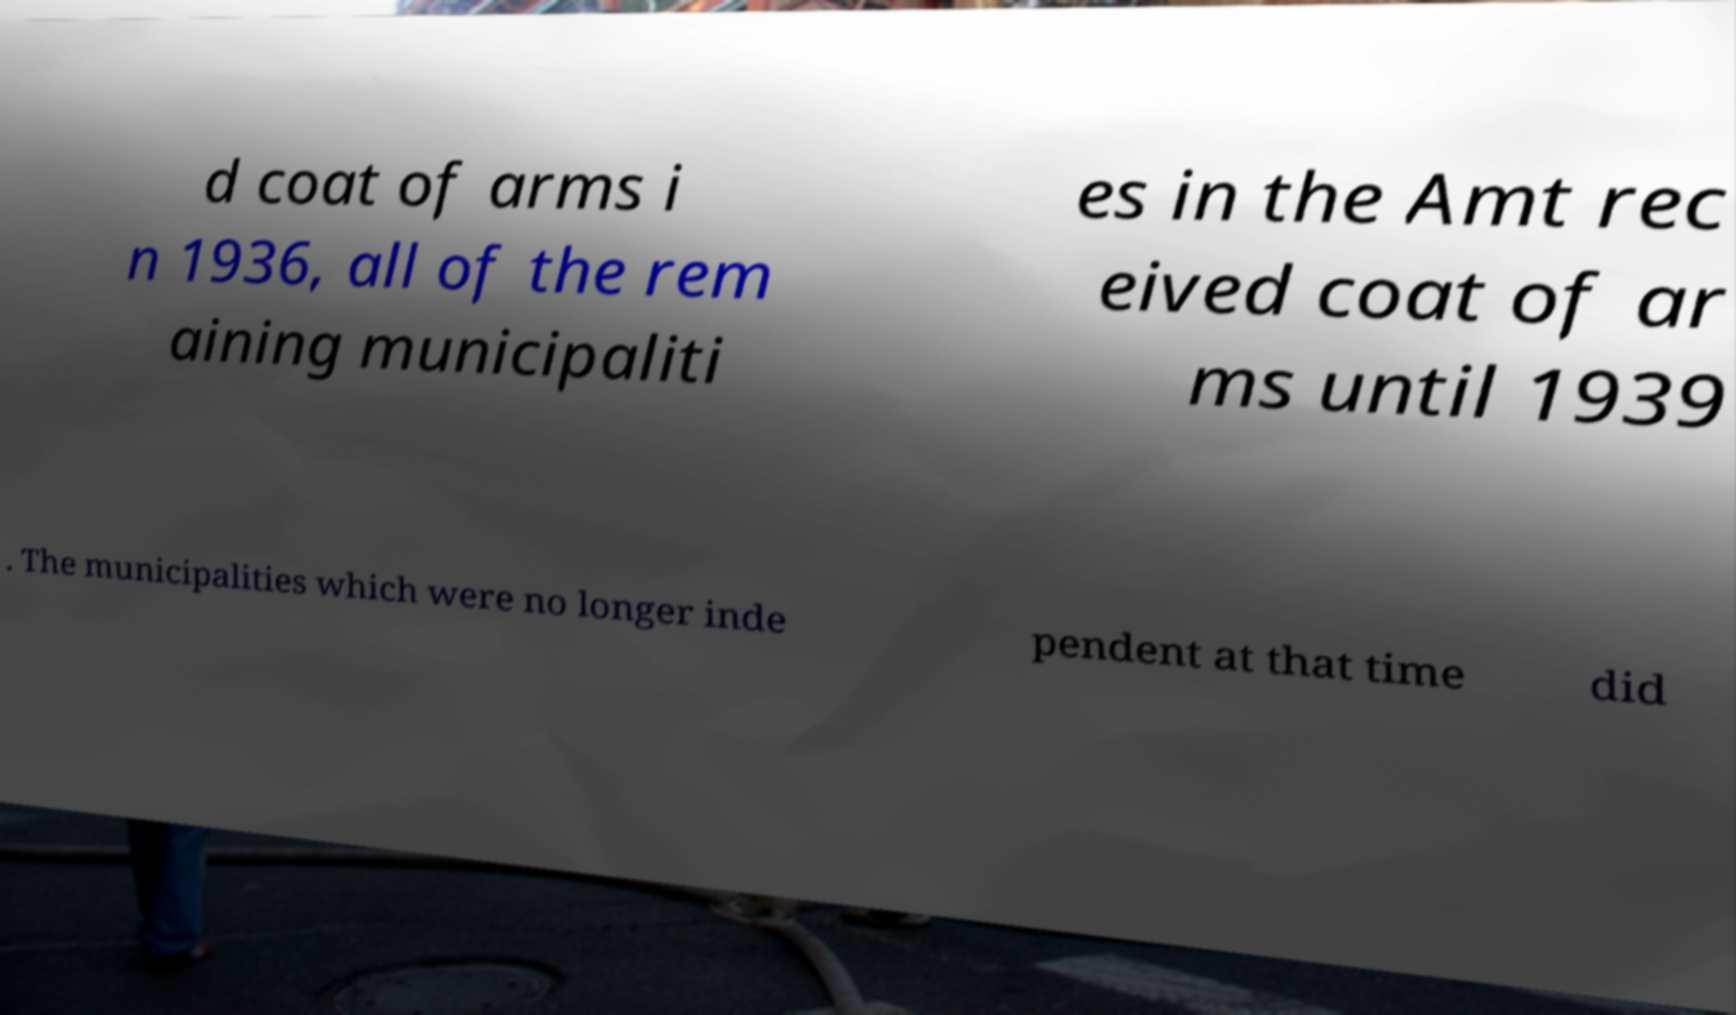There's text embedded in this image that I need extracted. Can you transcribe it verbatim? d coat of arms i n 1936, all of the rem aining municipaliti es in the Amt rec eived coat of ar ms until 1939 . The municipalities which were no longer inde pendent at that time did 